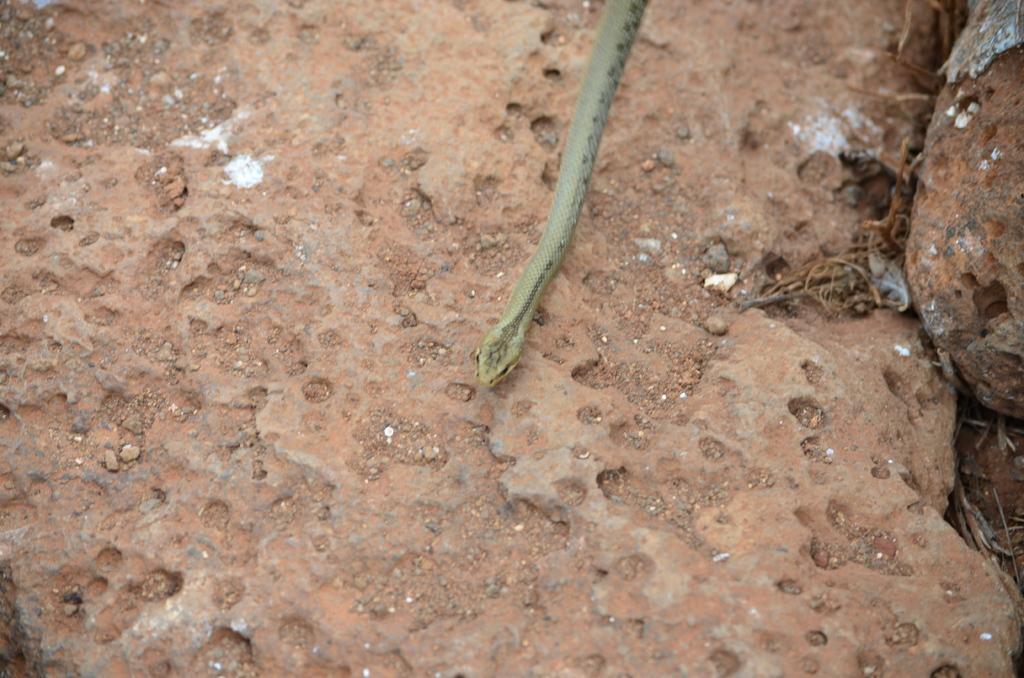Could you give a brief overview of what you see in this image? In this image we can see a snake lying on the ground. 